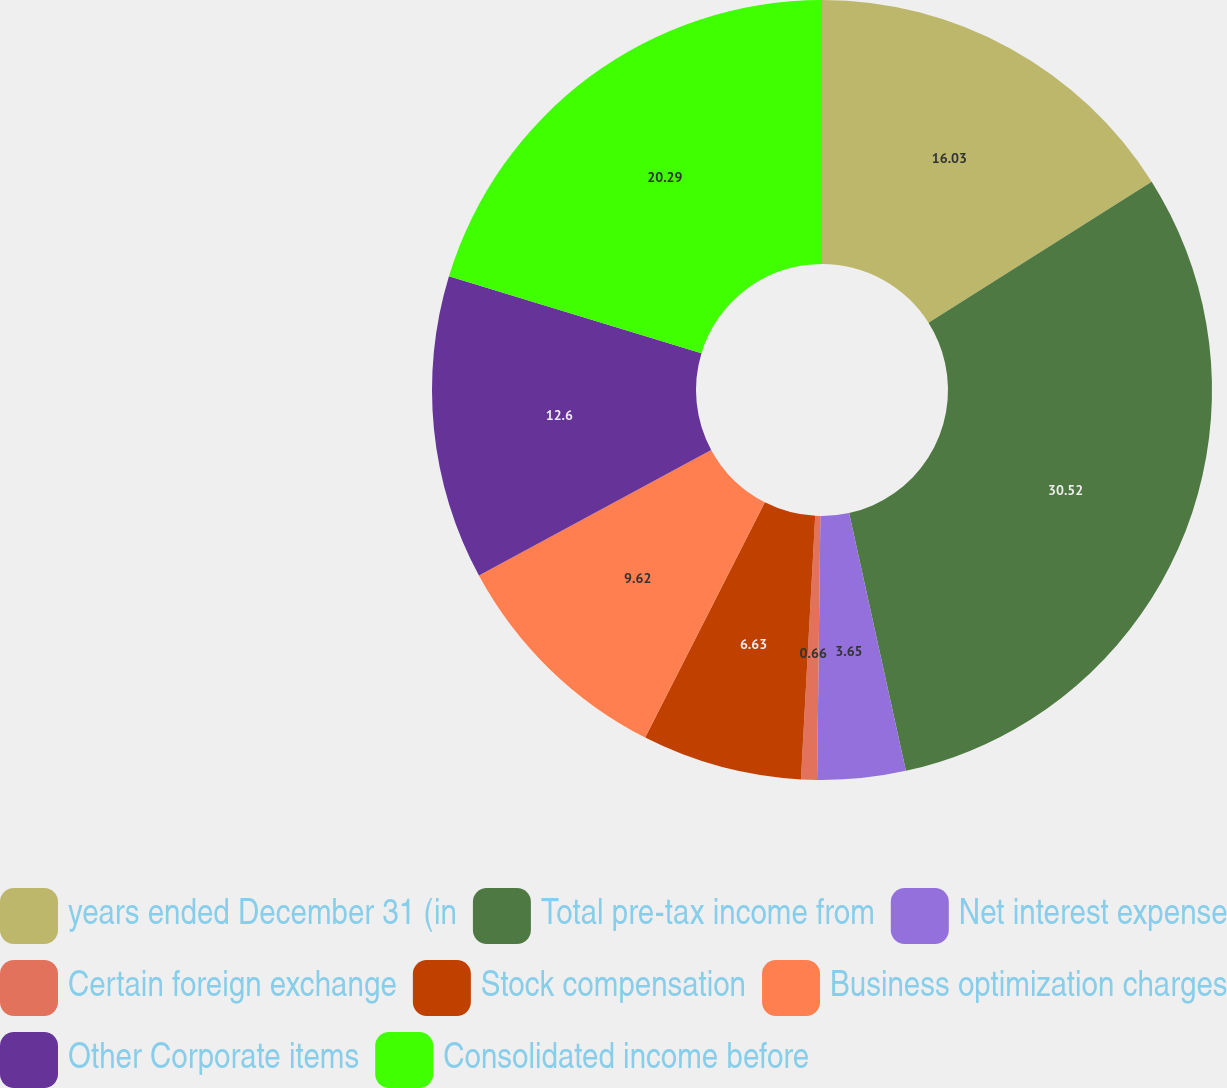Convert chart. <chart><loc_0><loc_0><loc_500><loc_500><pie_chart><fcel>years ended December 31 (in<fcel>Total pre-tax income from<fcel>Net interest expense<fcel>Certain foreign exchange<fcel>Stock compensation<fcel>Business optimization charges<fcel>Other Corporate items<fcel>Consolidated income before<nl><fcel>16.03%<fcel>30.52%<fcel>3.65%<fcel>0.66%<fcel>6.63%<fcel>9.62%<fcel>12.6%<fcel>20.29%<nl></chart> 